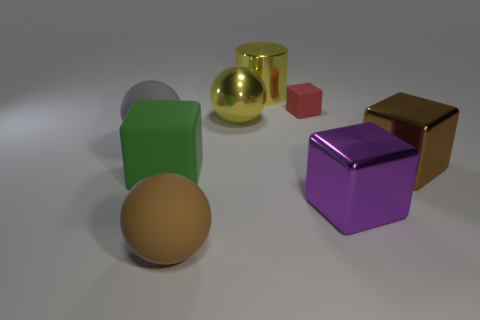Subtract all purple spheres. Subtract all gray cubes. How many spheres are left? 3 Add 2 yellow things. How many objects exist? 10 Subtract all balls. How many objects are left? 5 Add 1 gray matte things. How many gray matte things are left? 2 Add 6 large green cubes. How many large green cubes exist? 7 Subtract 0 green cylinders. How many objects are left? 8 Subtract all small cyan rubber balls. Subtract all big brown matte spheres. How many objects are left? 7 